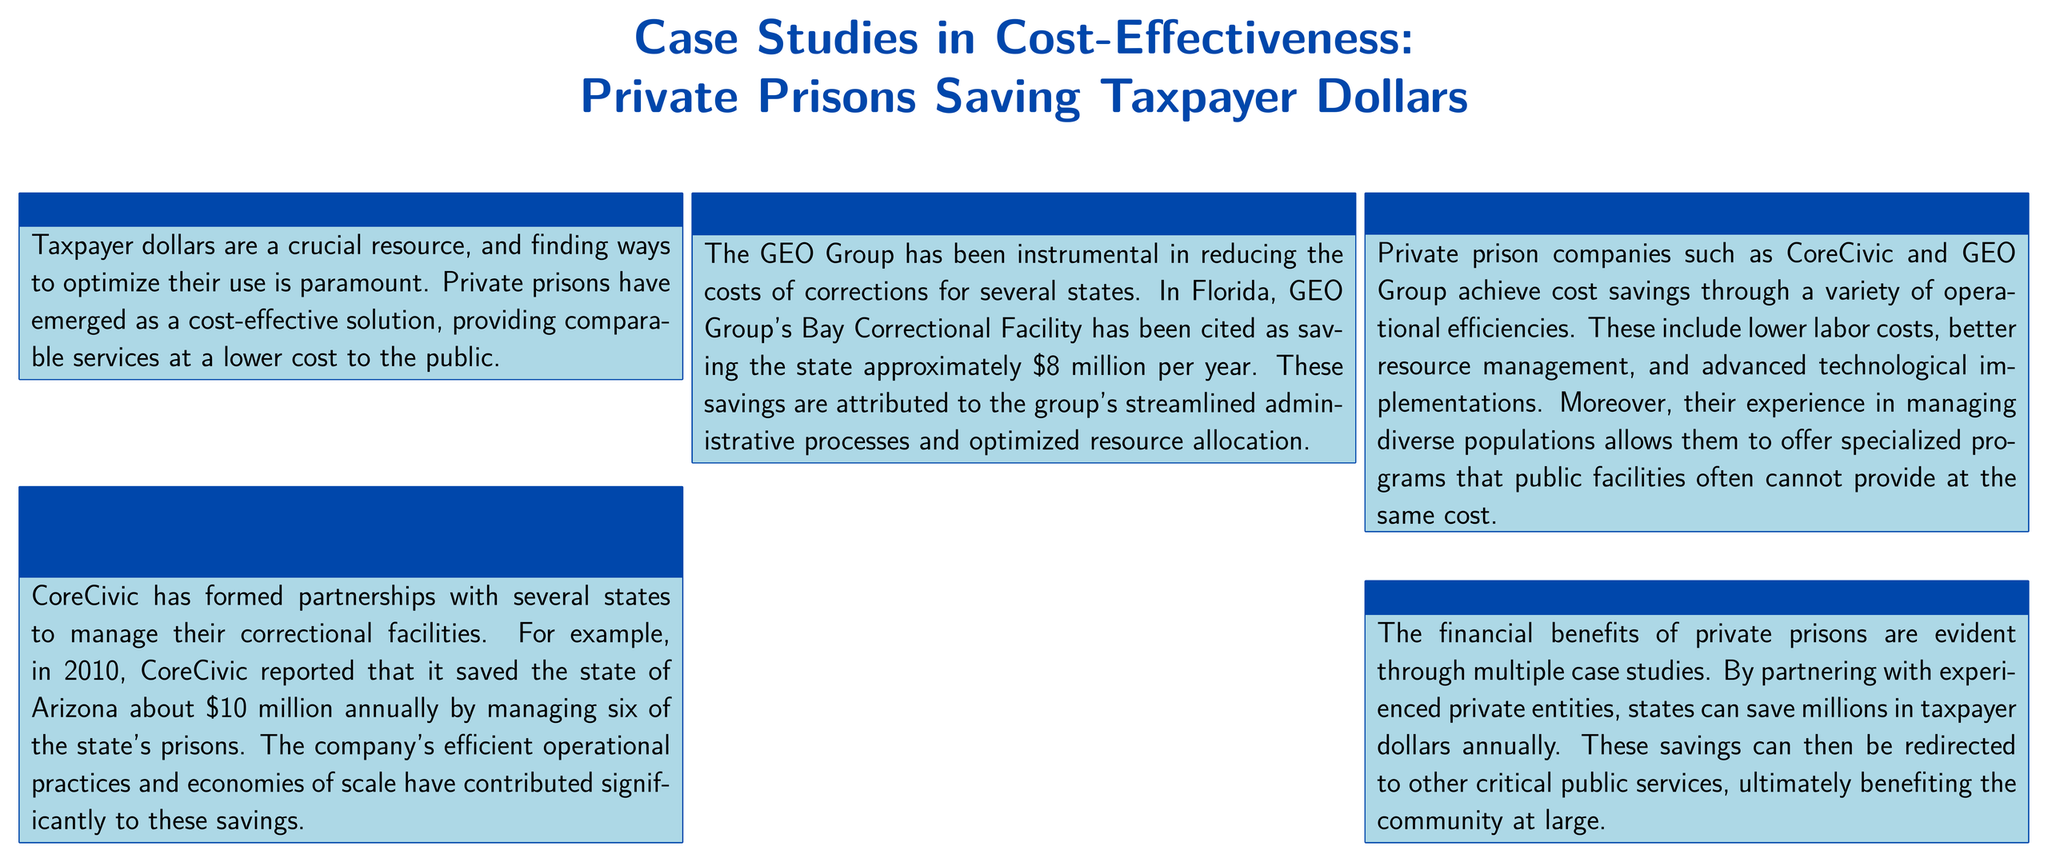what is the annual savings attributed to CoreCivic in Arizona? The annual savings attributed to CoreCivic in Arizona is mentioned in the case study, which states that it saved the state about $10 million annually.
Answer: $10 million what is the annual savings attributed to GEO Group's Bay Correctional Facility in Florida? The document mentions that GEO Group's Bay Correctional Facility has been cited as saving the state approximately $8 million per year.
Answer: $8 million what two companies are highlighted in the case studies? The document specifically mentions two companies: CoreCivic and GEO Group.
Answer: CoreCivic and GEO Group what operational efficiencies contribute to cost savings in private prisons? The discussion section cites lower labor costs, better resource management, and advanced technological implementations as operational efficiencies leading to cost savings.
Answer: Lower labor costs, better resource management, and advanced technological implementations what can the savings from private prisons be used for? The conclusion states that the savings can be redirected to other critical public services, benefiting the community at large.
Answer: Other critical public services in which year did CoreCivic report savings for Arizona? The case study about CoreCivic specifically references the year 2010 when their savings were reported for Arizona.
Answer: 2010 what is the primary focus of the poster? The overall focus of the poster is on case studies demonstrating the cost-effectiveness of private prisons in saving taxpayer dollars.
Answer: Cost-effectiveness of private prisons what visual format is used for presenting the information in the document? The document is presented in a poster format, using a combination of text and color boxes to organize the case studies and discussion points.
Answer: Poster format 